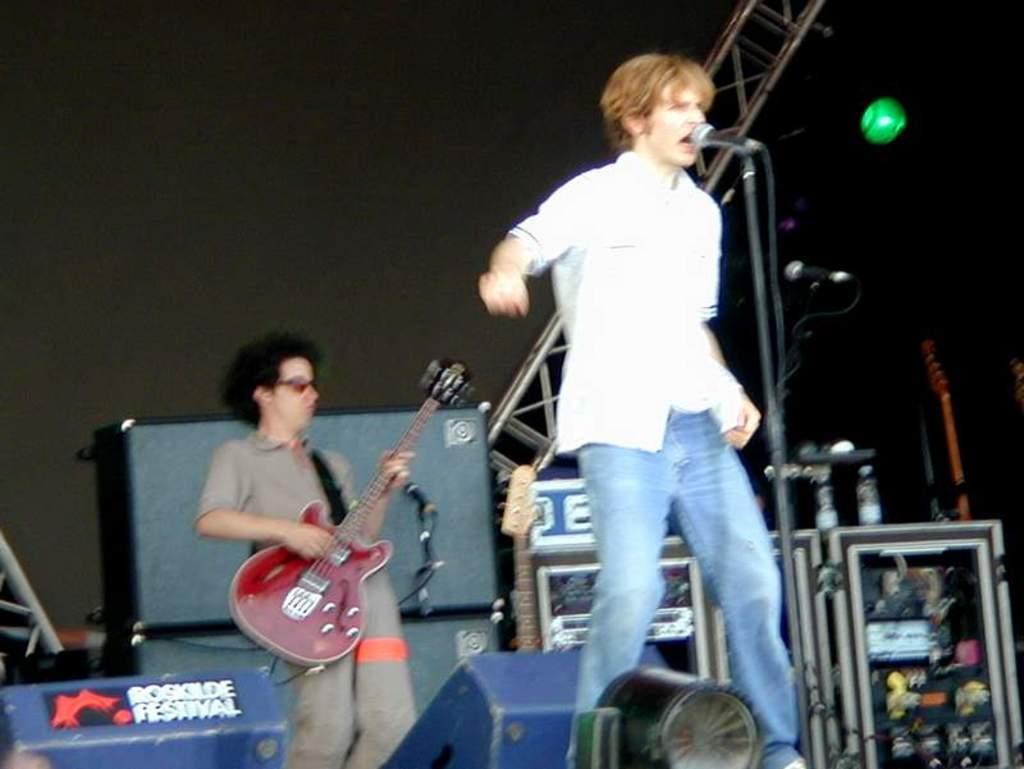In one or two sentences, can you explain what this image depicts? There are two people standing. One person is singing a song and the other person is playing guitar. This is a mike with the mike stand. At background I can see some devices placed. This looks like stage show where two men are performing. 